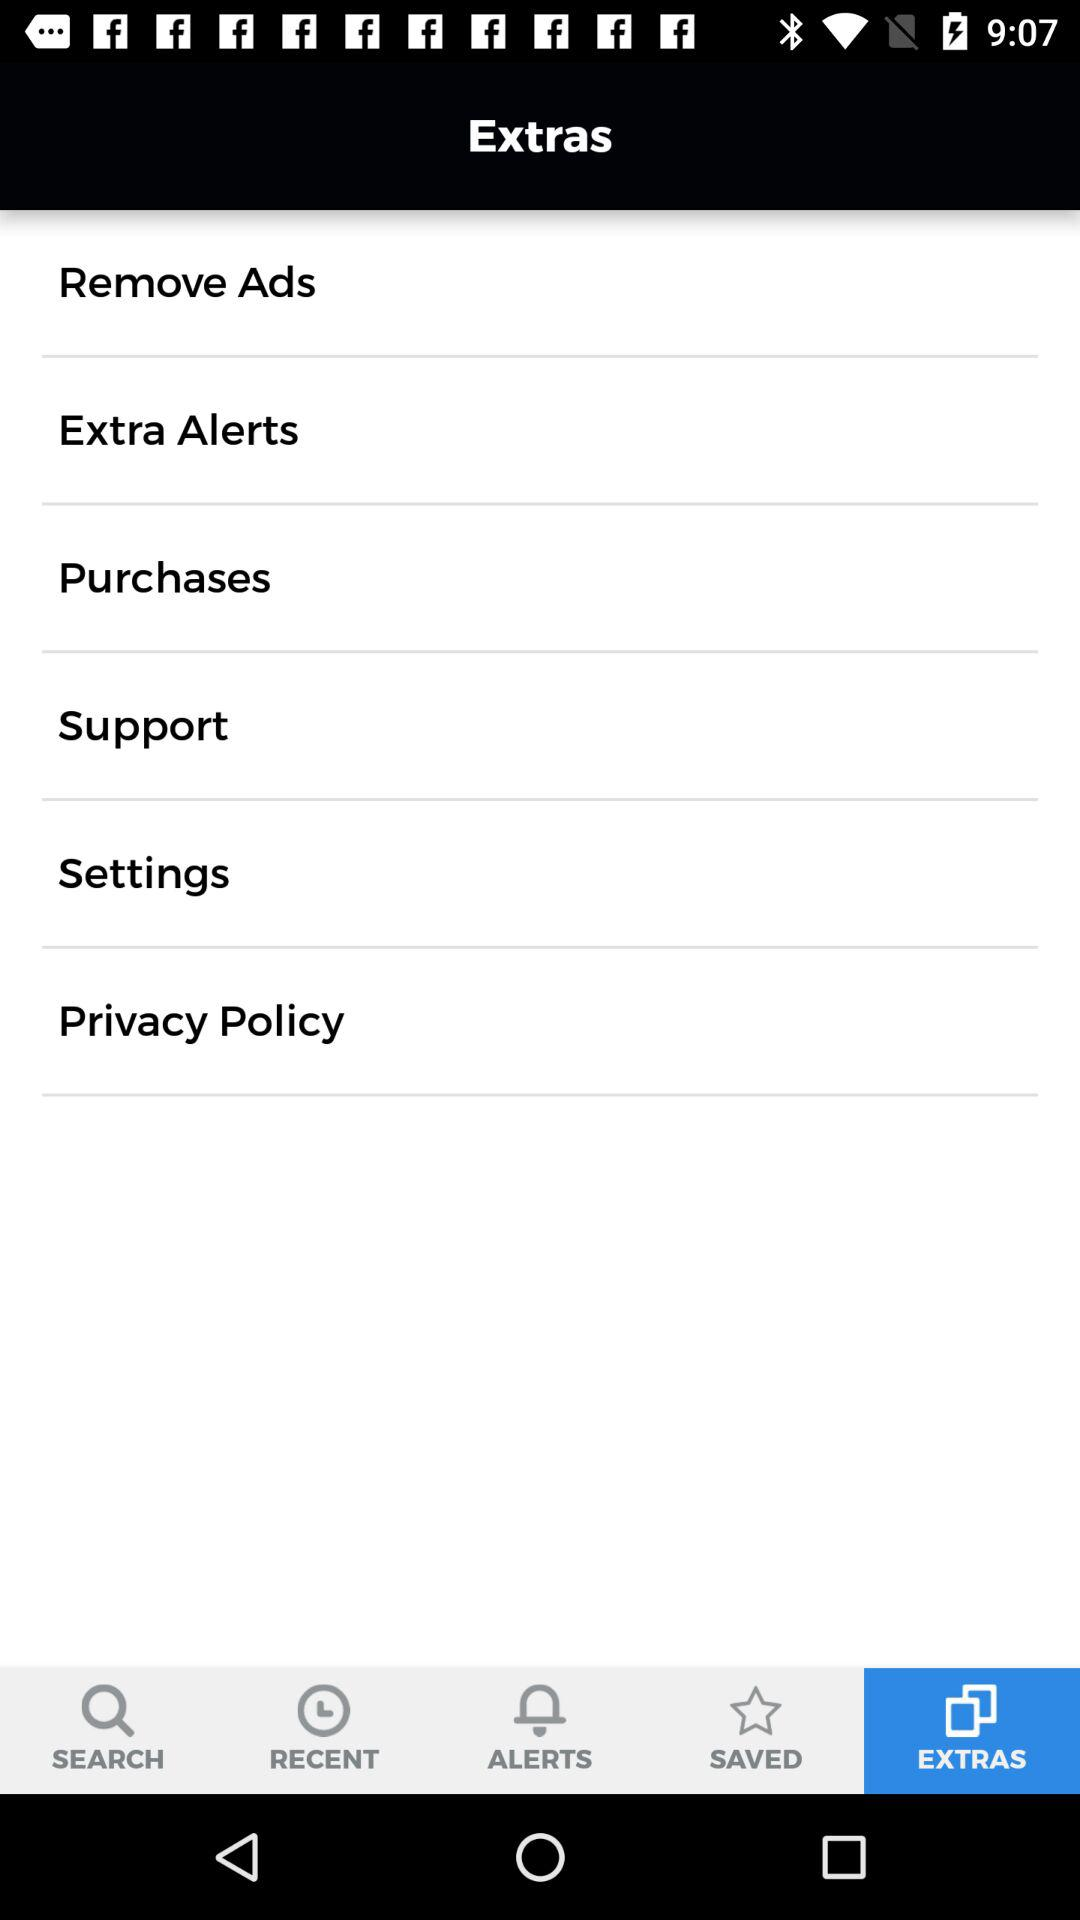Which tab is selected? The selected tab is "EXTRAS". 